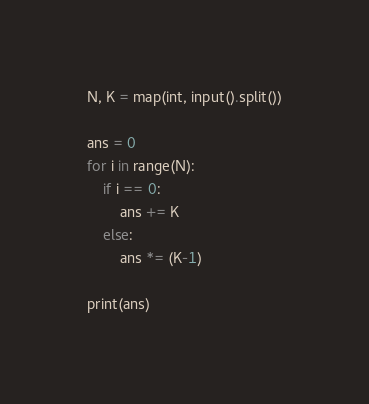Convert code to text. <code><loc_0><loc_0><loc_500><loc_500><_Python_>N, K = map(int, input().split())

ans = 0
for i in range(N):
    if i == 0:
        ans += K
    else:
        ans *= (K-1)

print(ans)
</code> 